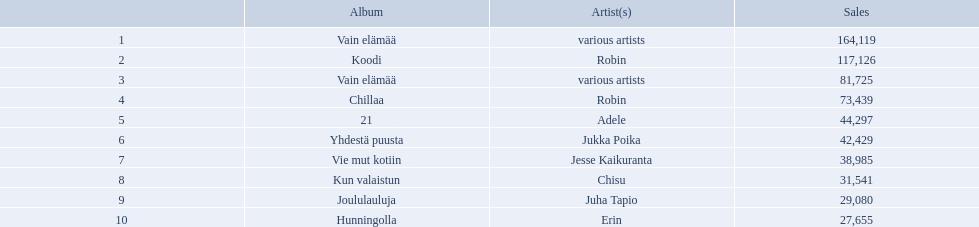Which were the number-one albums of 2012 in finland? Vain elämää, Koodi, Vain elämää, Chillaa, 21, Yhdestä puusta, Vie mut kotiin, Kun valaistun, Joululauluja, Hunningolla. Of those albums, which were by robin? Koodi, Chillaa. Of those albums by robin, which is not chillaa? Koodi. Who is the artist for 21 album? Adele. Who is the artist for kun valaistun? Chisu. Which album had the same artist as chillaa? Koodi. What are the entire album titles? Vain elämää, Koodi, Vain elämää, Chillaa, 21, Yhdestä puusta, Vie mut kotiin, Kun valaistun, Joululauluja, Hunningolla. Which artists were part of the albums? Various artists, robin, various artists, robin, adele, jukka poika, jesse kaikuranta, chisu, juha tapio, erin. In addition to chillaa, which other album showcased robin? Koodi. Which albums held the first place in 2012 in finland? Vain elämää, Koodi, Vain elämää, Chillaa, 21, Yhdestä puusta, Vie mut kotiin, Kun valaistun, Joululauluja, Hunningolla. Of these albums, which ones belonged to robin? Koodi, Chillaa. Of these albums by robin, which isn't chillaa? Koodi. What are adele's sales figures? 44,297. What are chisu's sales figures? 31,541. Which of these amounts is greater? 44,297. Who has this quantity of sales? Adele. Which albums secured the first place in finland's 2012 album charts? 1, Vain elämää, Koodi, Vain elämää, Chillaa, 21, Yhdestä puusta, Vie mut kotiin, Kun valaistun, Joululauluja, Hunningolla. Of these albums, which were the work of just one artist? Koodi, Chillaa, 21, Yhdestä puusta, Vie mut kotiin, Kun valaistun, Joululauluja, Hunningolla. Which albums sold between 30,000 and 45,000 copies? 21, Yhdestä puusta, Vie mut kotiin, Kun valaistun. Of these albums, which one boasted the highest sales numbers? 21. Who was the artist responsible for that album? Adele. What were the top-ranked albums of 2012 in finland? Vain elämää, Koodi, Vain elämää, Chillaa, 21, Yhdestä puusta, Vie mut kotiin, Kun valaistun, Joululauluja, Hunningolla. Of those albums, which were created by robin? Koodi, Chillaa. Of those albums by robin, which one is not chillaa? Koodi. Who is the musician behind the 21 album? Adele. Who is the musician for kun valaistun? Chisu. Which album shared the same musician as chillaa? Koodi. Who created the 21 album? Adele. Who is behind the kun valaistun album? Chisu. Which album shares the same creator as chillaa? Koodi. Who is responsible for the 21 album? Adele. Who made the kun valaistun album? Chisu. What other album has the same artist as chillaa? Koodi. 